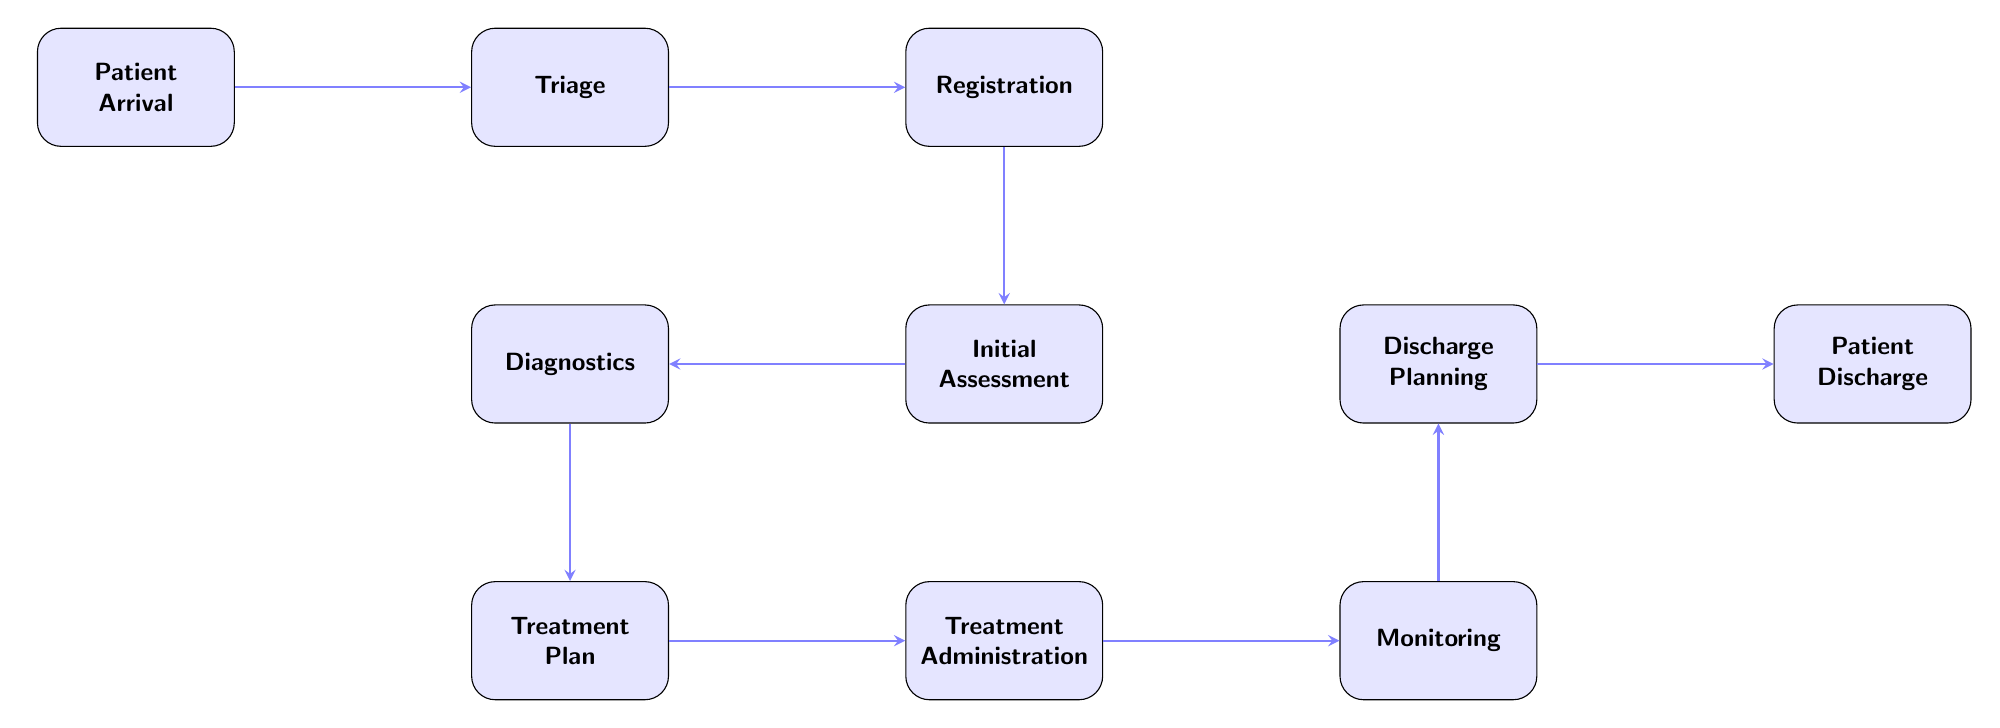What is the first step in the workflow? The first step is indicated as "Patient Arrival," which is the starting point of the process in the diagram.
Answer: Patient Arrival How many nodes are present in the diagram? The diagram contains a total of 9 nodes, which represent the various steps from patient admission to discharge.
Answer: 9 What step comes after Triage? The diagram shows that the step following Triage is Registration, connecting directly to it.
Answer: Registration What is the last step of the workflow? The final node in the sequence is labeled "Patient Discharge," which concludes the workflow process.
Answer: Patient Discharge Which step directly precedes Treatment Administration? According to the diagram, the step that comes immediately before Treatment Administration is the Treatment Plan.
Answer: Treatment Plan After which step does Monitoring occur? In the flow of the diagram, Monitoring occurs after Treatment Administration, indicating it is the subsequent step.
Answer: Treatment Administration Which node is positioned below Diagnostics? The diagram indicates that below Diagnostics is the node labeled Treatment Plan, showing the hierarchy and order of steps.
Answer: Treatment Plan What is the relationship between Discharge Planning and Monitoring? The diagram indicates that Discharge Planning is directly above Monitoring, illustrating the flow before reaching the discharge phase.
Answer: Above If a patient goes through Initial Assessment, what is the next step? After Initial Assessment, the next step that follows in the workflow is Diagnostics, as shown by the direct connection in the diagram.
Answer: Diagnostics 